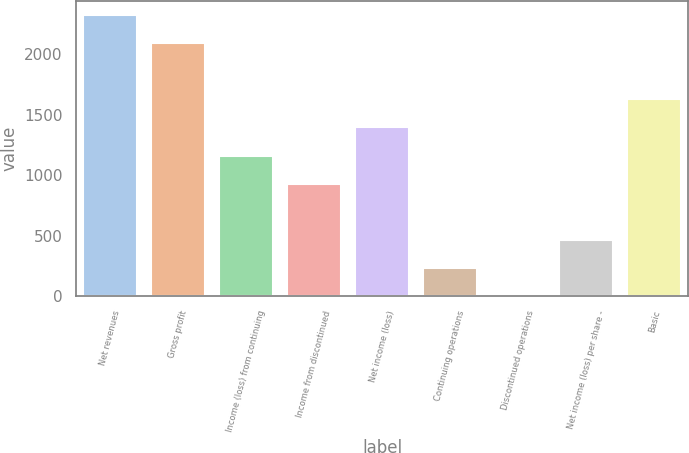Convert chart to OTSL. <chart><loc_0><loc_0><loc_500><loc_500><bar_chart><fcel>Net revenues<fcel>Gross profit<fcel>Income (loss) from continuing<fcel>Income from discontinued<fcel>Net income (loss)<fcel>Continuing operations<fcel>Discontinued operations<fcel>Net income (loss) per share -<fcel>Basic<nl><fcel>2323.04<fcel>2090.76<fcel>1161.64<fcel>929.36<fcel>1393.92<fcel>232.52<fcel>0.24<fcel>464.8<fcel>1626.2<nl></chart> 